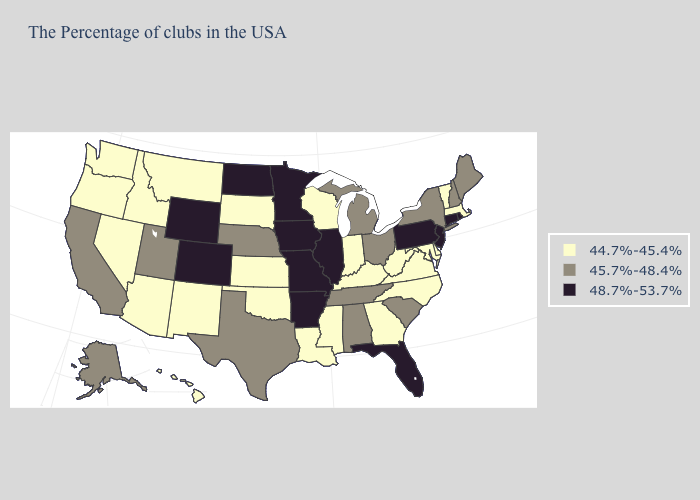Among the states that border North Carolina , does Georgia have the lowest value?
Short answer required. Yes. What is the value of Massachusetts?
Answer briefly. 44.7%-45.4%. Name the states that have a value in the range 48.7%-53.7%?
Write a very short answer. Rhode Island, Connecticut, New Jersey, Pennsylvania, Florida, Illinois, Missouri, Arkansas, Minnesota, Iowa, North Dakota, Wyoming, Colorado. Does Minnesota have the highest value in the USA?
Quick response, please. Yes. Among the states that border Massachusetts , which have the highest value?
Give a very brief answer. Rhode Island, Connecticut. What is the value of Iowa?
Short answer required. 48.7%-53.7%. Name the states that have a value in the range 48.7%-53.7%?
Quick response, please. Rhode Island, Connecticut, New Jersey, Pennsylvania, Florida, Illinois, Missouri, Arkansas, Minnesota, Iowa, North Dakota, Wyoming, Colorado. Which states hav the highest value in the MidWest?
Give a very brief answer. Illinois, Missouri, Minnesota, Iowa, North Dakota. Name the states that have a value in the range 48.7%-53.7%?
Keep it brief. Rhode Island, Connecticut, New Jersey, Pennsylvania, Florida, Illinois, Missouri, Arkansas, Minnesota, Iowa, North Dakota, Wyoming, Colorado. What is the highest value in the USA?
Short answer required. 48.7%-53.7%. What is the value of Massachusetts?
Concise answer only. 44.7%-45.4%. Name the states that have a value in the range 44.7%-45.4%?
Quick response, please. Massachusetts, Vermont, Delaware, Maryland, Virginia, North Carolina, West Virginia, Georgia, Kentucky, Indiana, Wisconsin, Mississippi, Louisiana, Kansas, Oklahoma, South Dakota, New Mexico, Montana, Arizona, Idaho, Nevada, Washington, Oregon, Hawaii. Name the states that have a value in the range 45.7%-48.4%?
Give a very brief answer. Maine, New Hampshire, New York, South Carolina, Ohio, Michigan, Alabama, Tennessee, Nebraska, Texas, Utah, California, Alaska. Name the states that have a value in the range 44.7%-45.4%?
Quick response, please. Massachusetts, Vermont, Delaware, Maryland, Virginia, North Carolina, West Virginia, Georgia, Kentucky, Indiana, Wisconsin, Mississippi, Louisiana, Kansas, Oklahoma, South Dakota, New Mexico, Montana, Arizona, Idaho, Nevada, Washington, Oregon, Hawaii. Does California have the same value as North Carolina?
Answer briefly. No. 